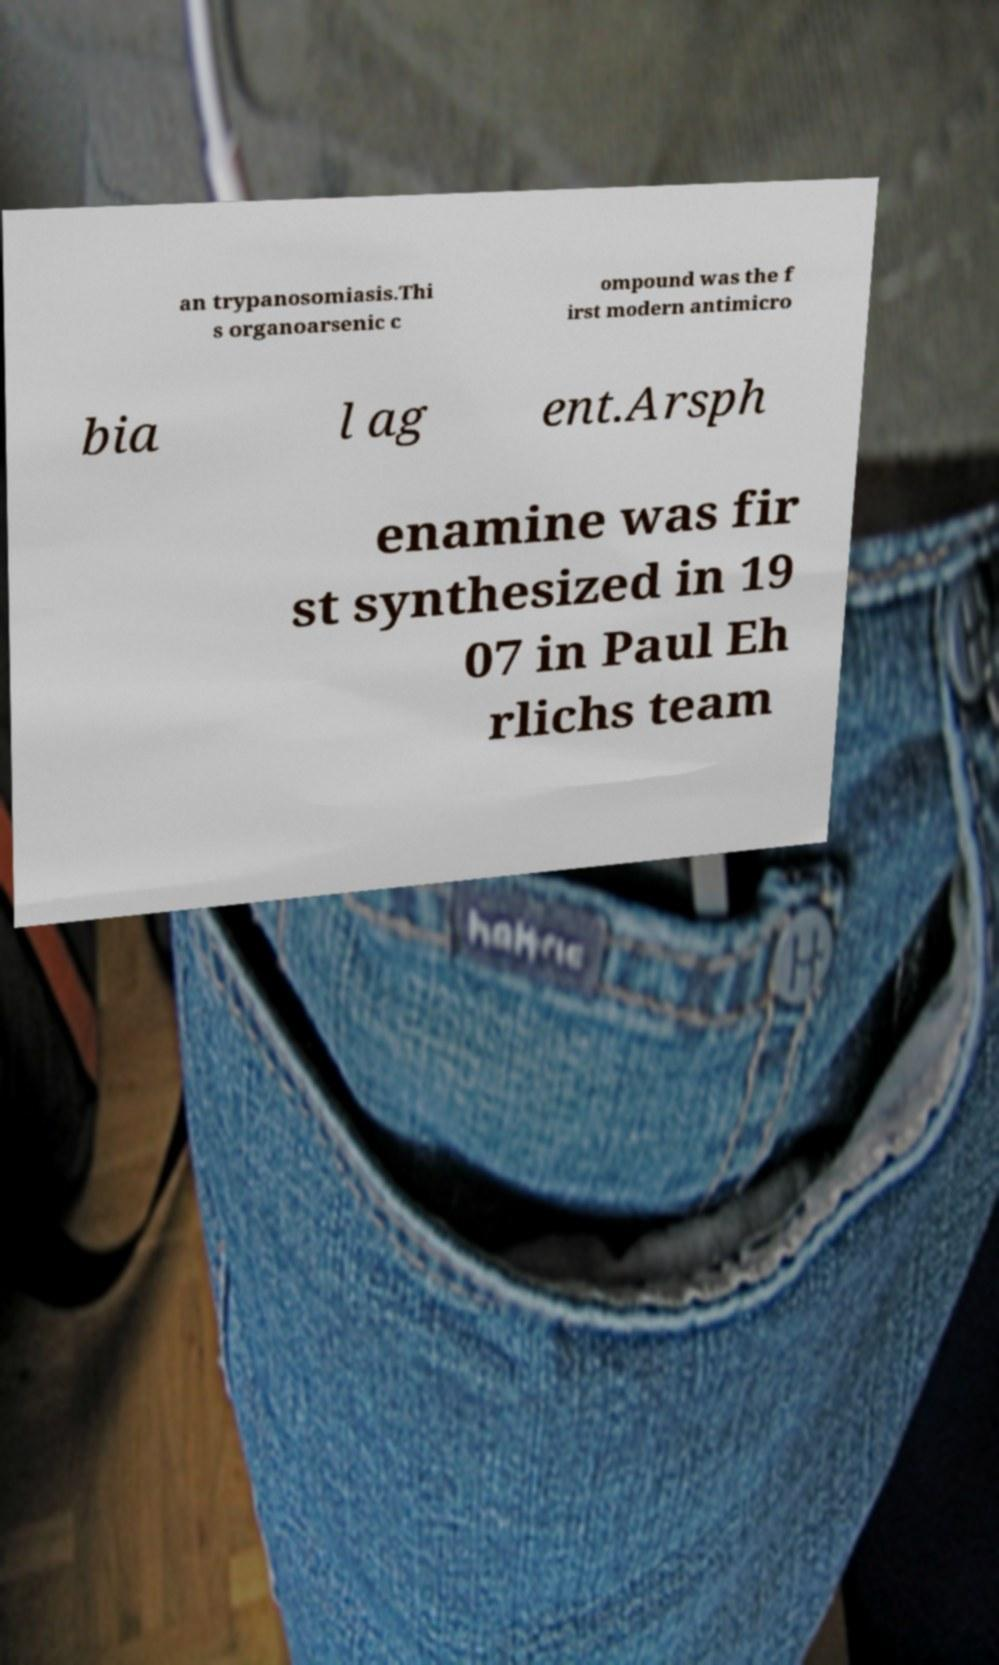Please read and relay the text visible in this image. What does it say? an trypanosomiasis.Thi s organoarsenic c ompound was the f irst modern antimicro bia l ag ent.Arsph enamine was fir st synthesized in 19 07 in Paul Eh rlichs team 